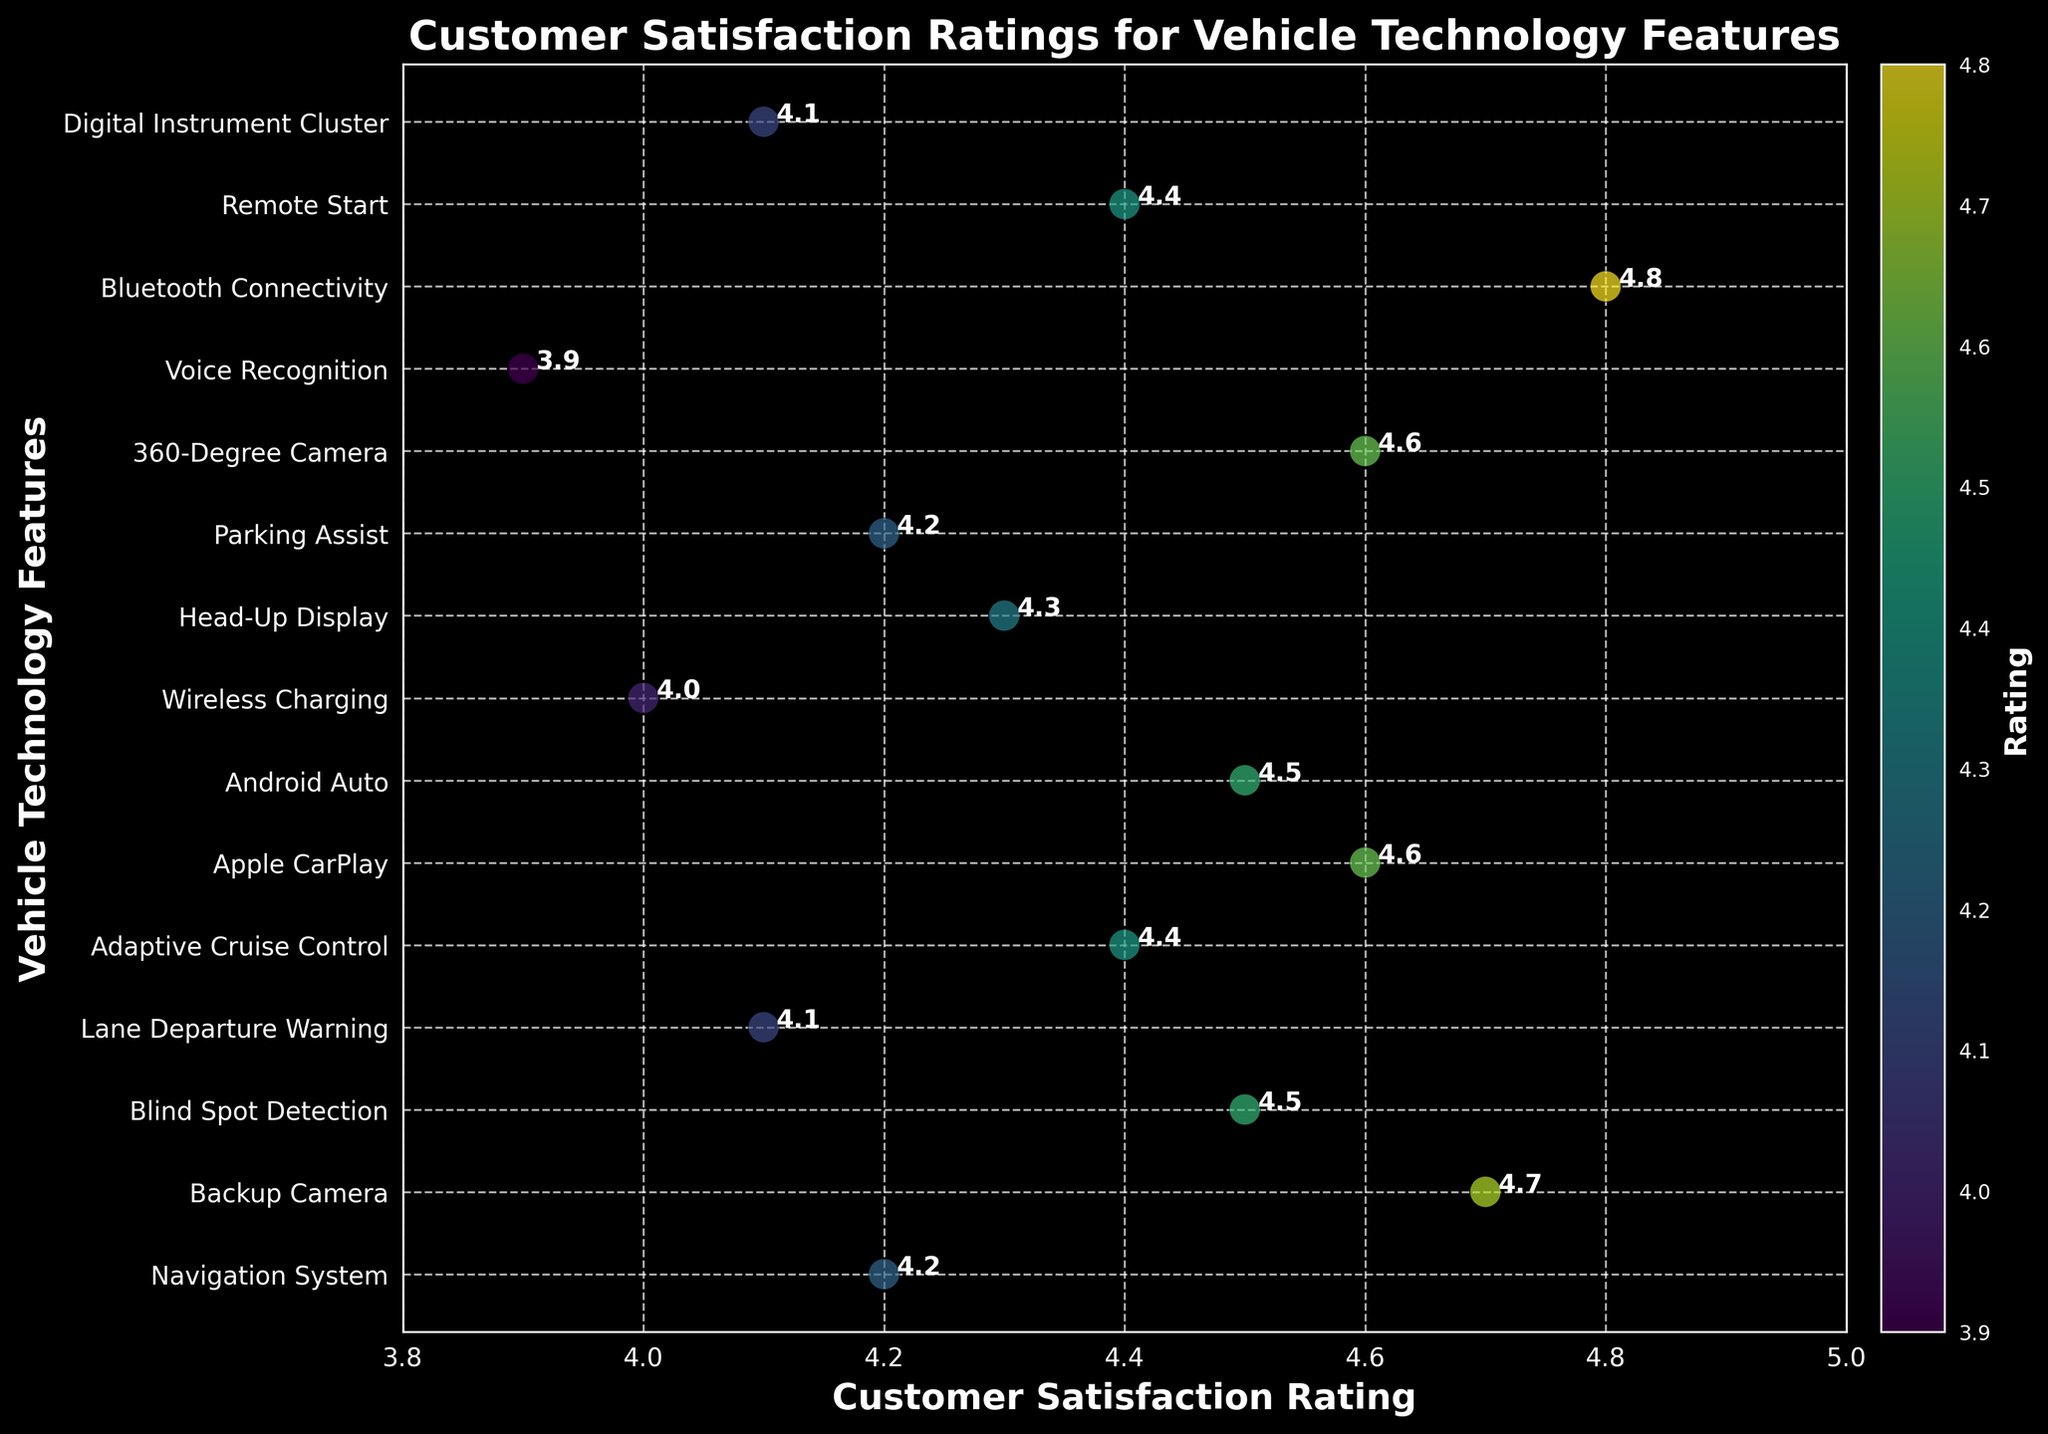What is the highest customer satisfaction rating for any vehicle technology feature? Identify the data point with the highest position on the x-axis. The highest rating is for Bluetooth Connectivity, which is 4.8.
Answer: 4.8 Which feature has the lowest customer satisfaction rating? Locate the data point placed lowest on the x-axis. Voice Recognition has the lowest rating at 3.9.
Answer: Voice Recognition How many vehicle technology features have a rating of 4.5 or above? Count the number of data points with a rating greater than or equal to 4.5. The features are Backup Camera, Blind Spot Detection, Apple CarPlay, Android Auto, 360-Degree Camera, and Bluetooth Connectivity. That's 6 features.
Answer: 6 Which features have the same customer satisfaction rating? Look for overlapping or close data points on the x-axis. Navigation System and Parking Assist both have a rating of 4.2, while Android Auto and Blind Spot Detection both have a rating of 4.5.
Answer: Navigation System & Parking Assist; Android Auto & Blind Spot Detection What is the range of customer satisfaction ratings for the listed vehicle technology features? Subtract the lowest rating from the highest rating. The highest rating is 4.8 for Bluetooth Connectivity, and the lowest is 3.9 for Voice Recognition. Therefore, the range is 4.8 - 3.9 = 0.9.
Answer: 0.9 Which feature has a higher rating, Head-Up Display or Digital Instrument Cluster? Compare the positions of the two data points on the x-axis. Head-Up Display's rating is 4.3, while Digital Instrument Cluster's rating is 4.1. Therefore, Head-Up Display has a higher rating.
Answer: Head-Up Display What is the average customer satisfaction rating for the features in the dataset? Sum all the ratings and divide by the number of features. The sum of all ratings is 61.1, and there are 15 features. Therefore, the average rating is 61.1 / 15 = 4.07.
Answer: 4.07 Which feature is rated exactly 4.4? Identify the data point positioned exactly at the 4.4 mark on the x-axis. The features with this rating are Adaptive Cruise Control and Remote Start.
Answer: Adaptive Cruise Control & Remote Start What can you say about the distribution of the ratings overall? Observe the spread of data points along the x-axis to describe the overall pattern. The majority of the ratings are tightly clustered between 4.0 and 4.8, indicating overall high customer satisfaction with vehicle technology features.
Answer: High satisfaction with clustering between 4.0 and 4.8 